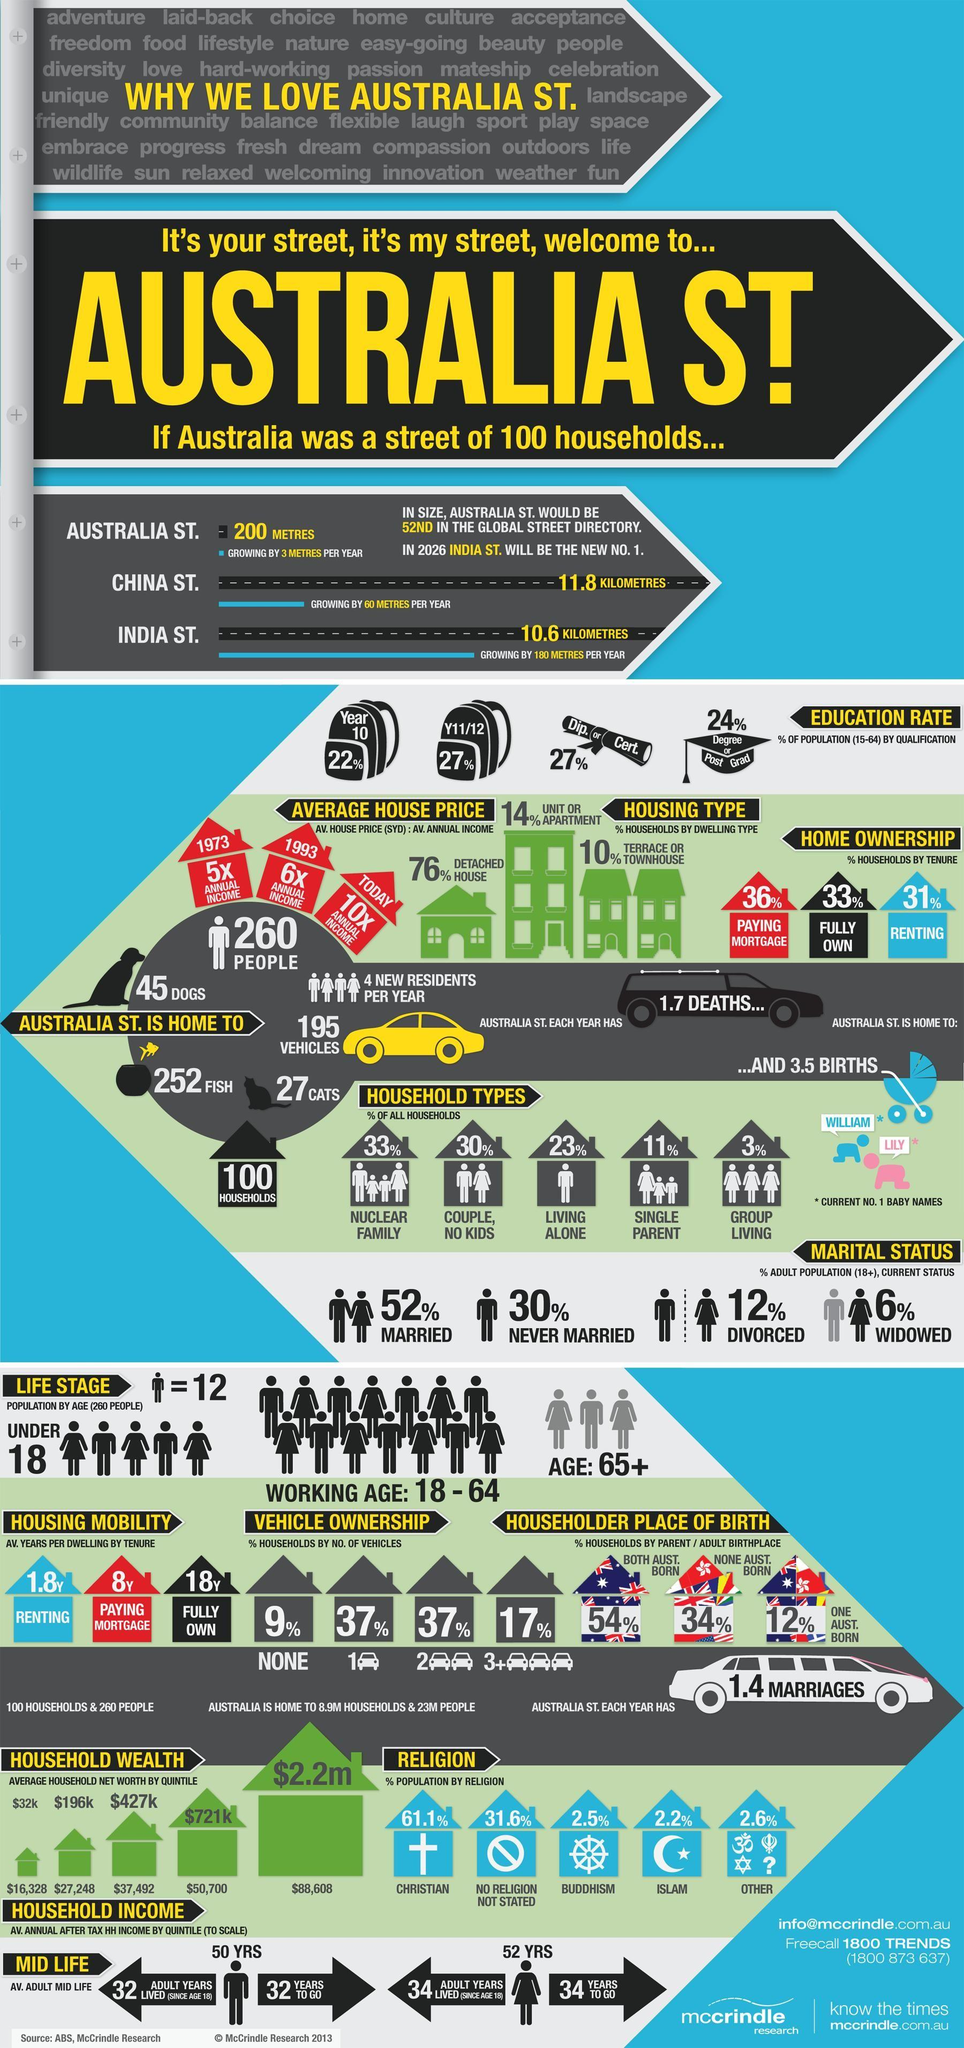Point out several critical features in this image. In Australia, the most common type of household is a nuclear family. INDIA STREET is the fastest growing street in the country. Approximately 27% of the population holds a diploma or certificate. The predominant religious faith among people is Christianity. The popular male baby name in Australia is William. 